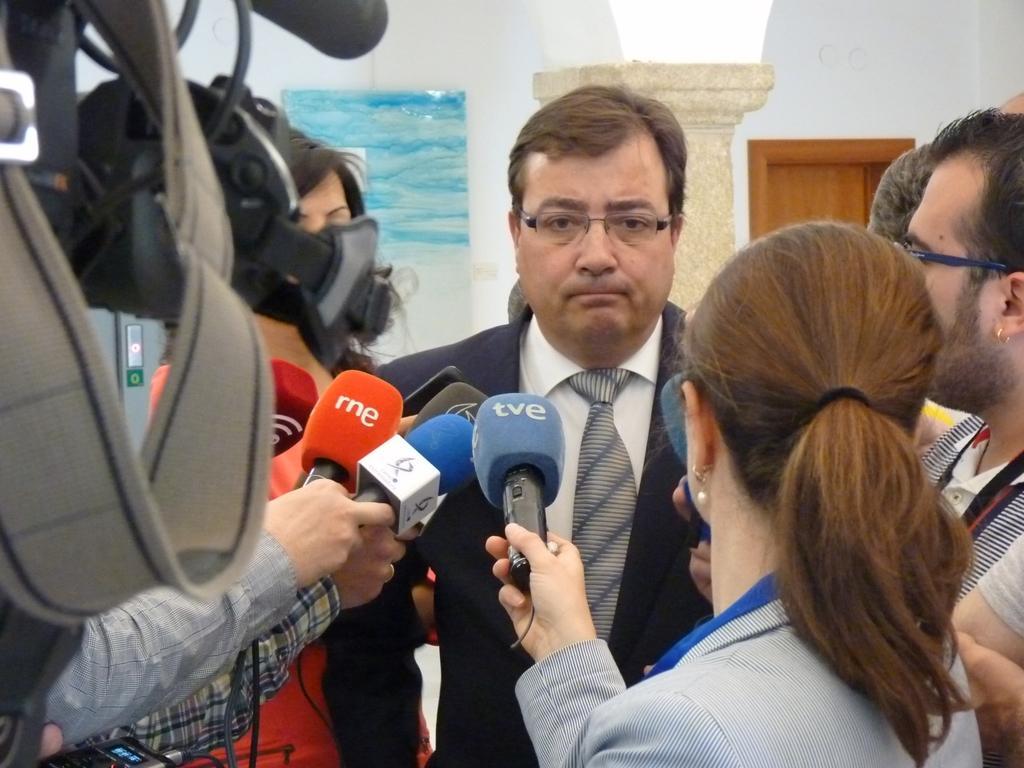Describe this image in one or two sentences. In this picture I can see a man in the middle, few persons are holding the microphones around him, on the left side there is a camera. 